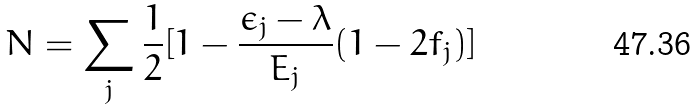Convert formula to latex. <formula><loc_0><loc_0><loc_500><loc_500>N = \sum _ { j } \frac { 1 } { 2 } [ 1 - \frac { \epsilon _ { j } - \lambda } { E _ { j } } ( 1 - 2 f _ { j } ) ]</formula> 